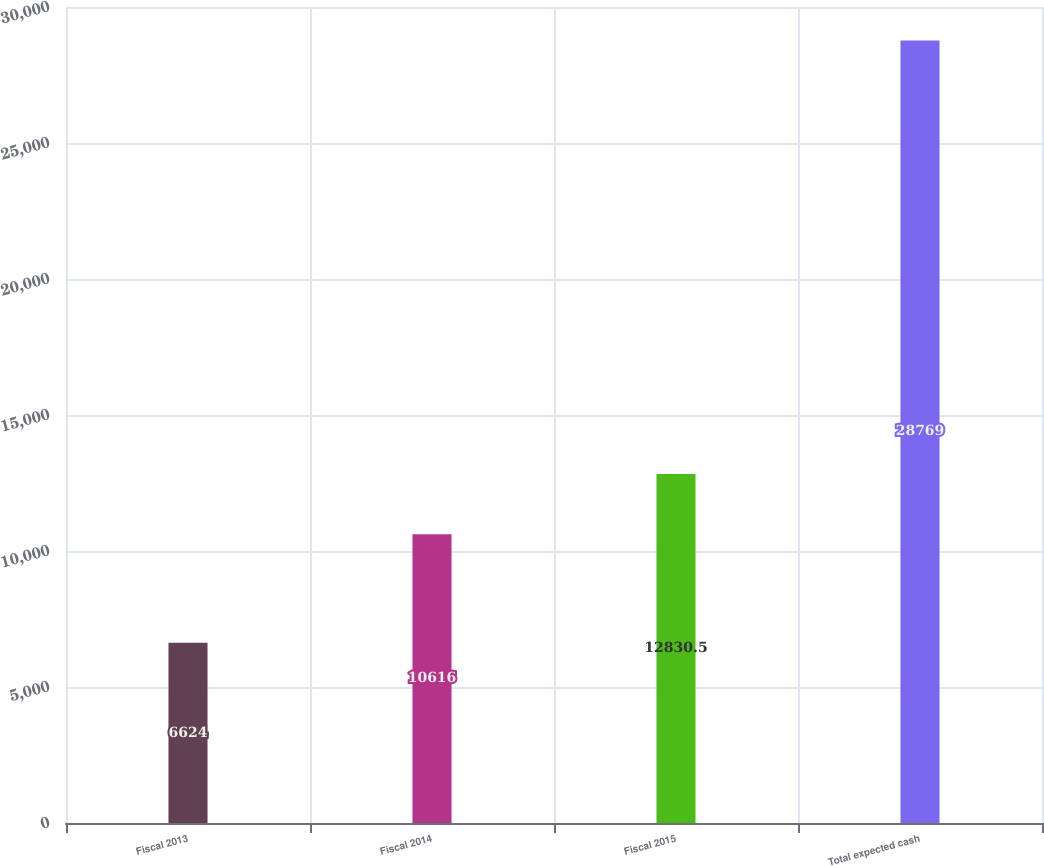Convert chart to OTSL. <chart><loc_0><loc_0><loc_500><loc_500><bar_chart><fcel>Fiscal 2013<fcel>Fiscal 2014<fcel>Fiscal 2015<fcel>Total expected cash<nl><fcel>6624<fcel>10616<fcel>12830.5<fcel>28769<nl></chart> 